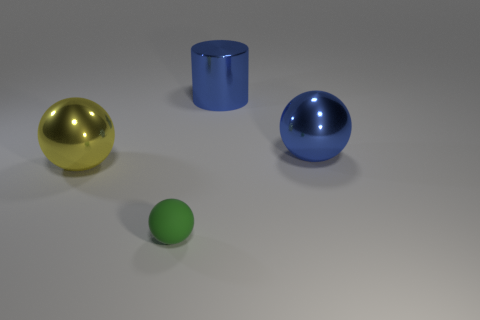There is another small rubber thing that is the same shape as the yellow thing; what color is it?
Provide a succinct answer. Green. What shape is the large blue metallic thing that is left of the large metal ball that is to the right of the large shiny thing that is left of the tiny rubber thing?
Provide a short and direct response. Cylinder. What is the size of the object that is both to the right of the large yellow object and left of the big blue cylinder?
Your response must be concise. Small. Is the number of big metal spheres less than the number of small blocks?
Your answer should be compact. No. What is the size of the green rubber object in front of the large blue shiny ball?
Provide a succinct answer. Small. The thing that is both behind the big yellow thing and in front of the large blue metallic cylinder has what shape?
Offer a very short reply. Sphere. What is the size of the blue thing that is the same shape as the small green object?
Offer a terse response. Large. How many other big spheres are made of the same material as the large yellow sphere?
Offer a very short reply. 1. Does the big cylinder have the same color as the ball to the right of the small green rubber ball?
Offer a very short reply. Yes. Are there more small rubber spheres than small red matte blocks?
Provide a short and direct response. Yes. 